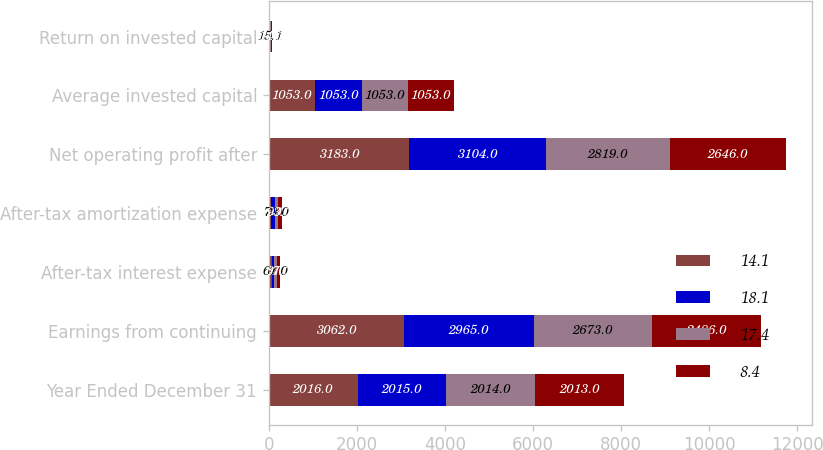Convert chart to OTSL. <chart><loc_0><loc_0><loc_500><loc_500><stacked_bar_chart><ecel><fcel>Year Ended December 31<fcel>Earnings from continuing<fcel>After-tax interest expense<fcel>After-tax amortization expense<fcel>Net operating profit after<fcel>Average invested capital<fcel>Return on invested capital<nl><fcel>14.1<fcel>2016<fcel>3062<fcel>64<fcel>57<fcel>3183<fcel>1053<fcel>18.1<nl><fcel>18.1<fcel>2015<fcel>2965<fcel>64<fcel>75<fcel>3104<fcel>1053<fcel>17.4<nl><fcel>17.4<fcel>2014<fcel>2673<fcel>67<fcel>79<fcel>2819<fcel>1053<fcel>15.1<nl><fcel>8.4<fcel>2013<fcel>2486<fcel>67<fcel>93<fcel>2646<fcel>1053<fcel>14.1<nl></chart> 